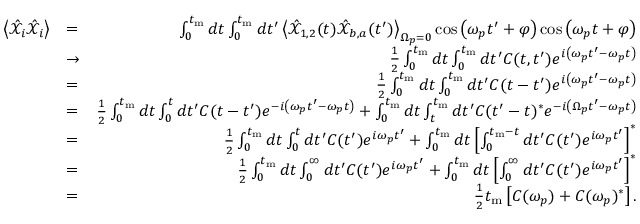Convert formula to latex. <formula><loc_0><loc_0><loc_500><loc_500>\begin{array} { r l r } { \left < \hat { \mathcal { X } } _ { i } \hat { \mathcal { X } } _ { i } \right > } & { = } & { \int _ { 0 } ^ { t _ { m } } d t \int _ { 0 } ^ { t _ { m } } d t ^ { \prime } \left < \hat { \mathcal { X } } _ { 1 , 2 } ( t ) \hat { \mathcal { X } } _ { b , a } ( t ^ { \prime } ) \right > _ { \Omega _ { p } = 0 } \cos \left ( \omega _ { p } t ^ { \prime } + \varphi \right ) \cos \left ( \omega _ { p } t + \varphi \right ) } \\ & { \rightarrow } & { \frac { 1 } { 2 } \int _ { 0 } ^ { t _ { m } } d t \int _ { 0 } ^ { t _ { m } } d t ^ { \prime } C ( t , t ^ { \prime } ) e ^ { i \left ( \omega _ { p } t ^ { \prime } - \omega _ { p } t \right ) } } \\ & { = } & { \frac { 1 } { 2 } \int _ { 0 } ^ { t _ { m } } d t \int _ { 0 } ^ { t _ { m } } d t ^ { \prime } C ( t - t ^ { \prime } ) e ^ { i \left ( \omega _ { p } t ^ { \prime } - \omega _ { p } t \right ) } } \\ & { = } & { \frac { 1 } { 2 } \int _ { 0 } ^ { t _ { m } } d t \int _ { 0 } ^ { t } d t ^ { \prime } C ( t - t ^ { \prime } ) e ^ { - i \left ( \omega _ { p } t ^ { \prime } - \omega _ { p } t \right ) } + \int _ { 0 } ^ { t _ { m } } d t \int _ { t } ^ { t _ { m } } d t ^ { \prime } C ( t ^ { \prime } - t ) ^ { * } e ^ { - i \left ( \Omega _ { p } t ^ { \prime } - \omega _ { p } t \right ) } } \\ & { = } & { \frac { 1 } { 2 } \int _ { 0 } ^ { t _ { m } } d t \int _ { 0 } ^ { t } d t ^ { \prime } C ( t ^ { \prime } ) e ^ { i \omega _ { p } t ^ { \prime } } + \int _ { 0 } ^ { t _ { m } } d t \left [ \int _ { 0 } ^ { t _ { m } - t } d t ^ { \prime } C ( t ^ { \prime } ) e ^ { i \omega _ { p } t ^ { \prime } } \right ] ^ { * } } \\ & { = } & { \frac { 1 } { 2 } \int _ { 0 } ^ { t _ { m } } d t \int _ { 0 } ^ { \infty } d t ^ { \prime } C ( t ^ { \prime } ) e ^ { i \omega _ { p } t ^ { \prime } } + \int _ { 0 } ^ { t _ { m } } d t \left [ \int _ { 0 } ^ { \infty } d t ^ { \prime } C ( t ^ { \prime } ) e ^ { i \omega _ { p } t ^ { \prime } } \right ] ^ { * } } \\ & { = } & { \frac { 1 } { 2 } t _ { m } \left [ C ( \omega _ { p } ) + C ( \omega _ { p } ) ^ { * } \right ] . } \end{array}</formula> 